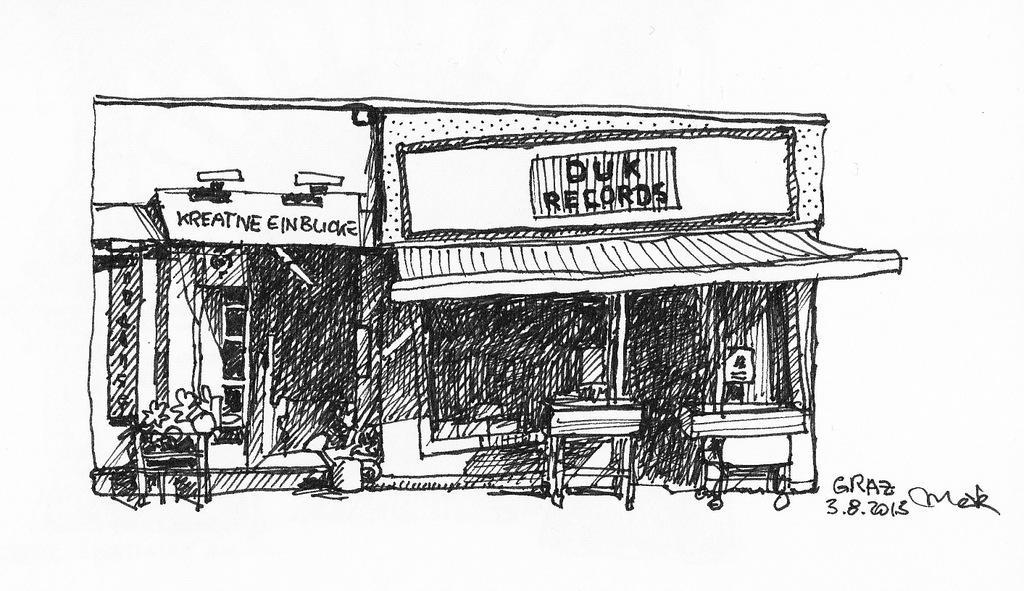How would you summarize this image in a sentence or two? In the center of the image we can see some drawing of a building,tables and a few other objects. And we can see some text on it. 